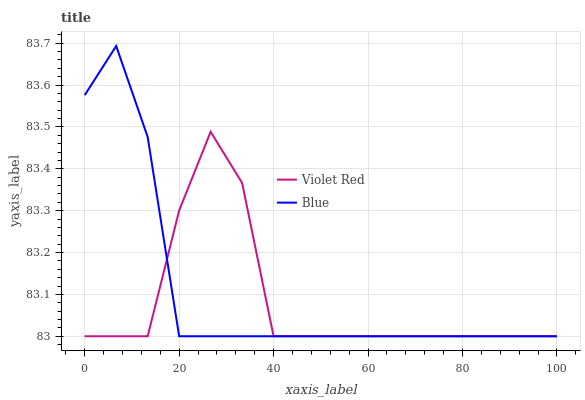Does Violet Red have the minimum area under the curve?
Answer yes or no. Yes. Does Blue have the maximum area under the curve?
Answer yes or no. Yes. Does Violet Red have the maximum area under the curve?
Answer yes or no. No. Is Blue the smoothest?
Answer yes or no. Yes. Is Violet Red the roughest?
Answer yes or no. Yes. Is Violet Red the smoothest?
Answer yes or no. No. Does Blue have the lowest value?
Answer yes or no. Yes. Does Blue have the highest value?
Answer yes or no. Yes. Does Violet Red have the highest value?
Answer yes or no. No. Does Violet Red intersect Blue?
Answer yes or no. Yes. Is Violet Red less than Blue?
Answer yes or no. No. Is Violet Red greater than Blue?
Answer yes or no. No. 